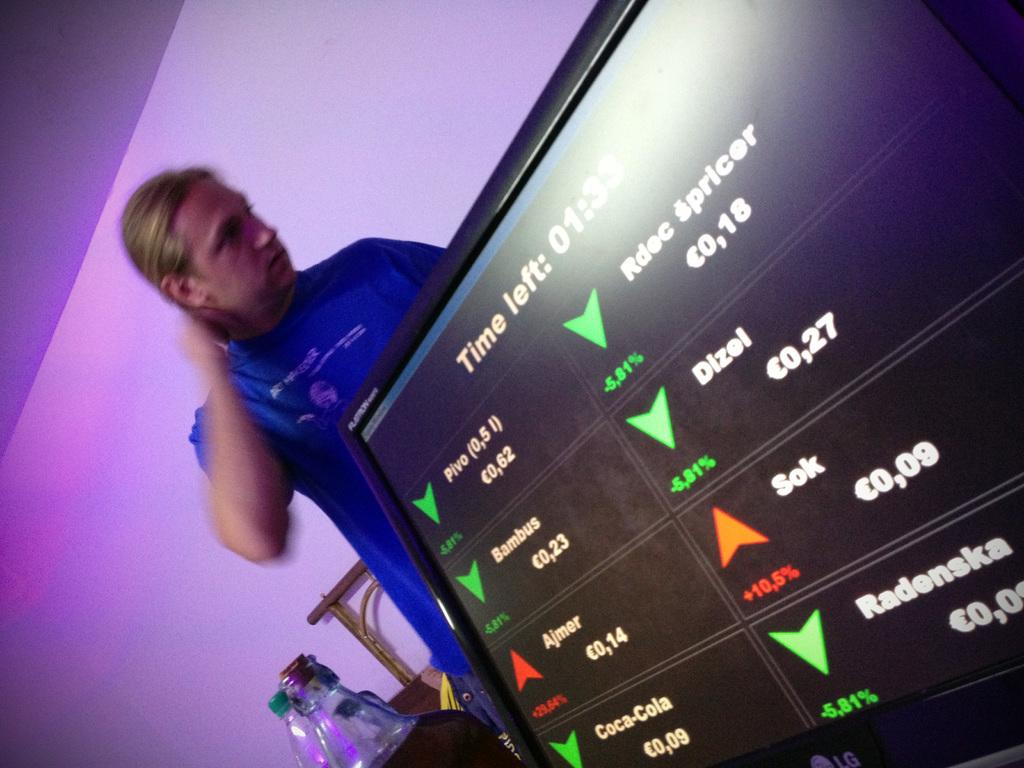<image>
Write a terse but informative summary of the picture. A man standing behind a TV screen that lists several stocks including Dizel that says "Time left" 